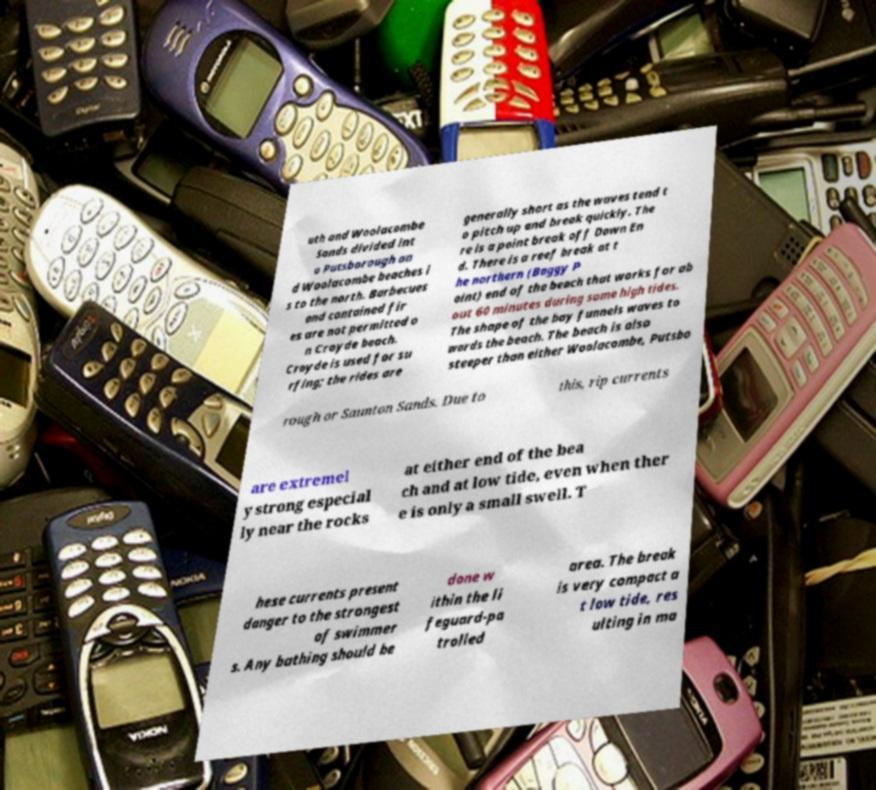For documentation purposes, I need the text within this image transcribed. Could you provide that? uth and Woolacombe Sands divided int o Putsborough an d Woolacombe beaches i s to the north. Barbecues and contained fir es are not permitted o n Croyde beach. Croyde is used for su rfing; the rides are generally short as the waves tend t o pitch up and break quickly. The re is a point break off Down En d. There is a reef break at t he northern (Baggy P oint) end of the beach that works for ab out 60 minutes during some high tides. The shape of the bay funnels waves to wards the beach. The beach is also steeper than either Woolacombe, Putsbo rough or Saunton Sands. Due to this, rip currents are extremel y strong especial ly near the rocks at either end of the bea ch and at low tide, even when ther e is only a small swell. T hese currents present danger to the strongest of swimmer s. Any bathing should be done w ithin the li feguard-pa trolled area. The break is very compact a t low tide, res ulting in ma 